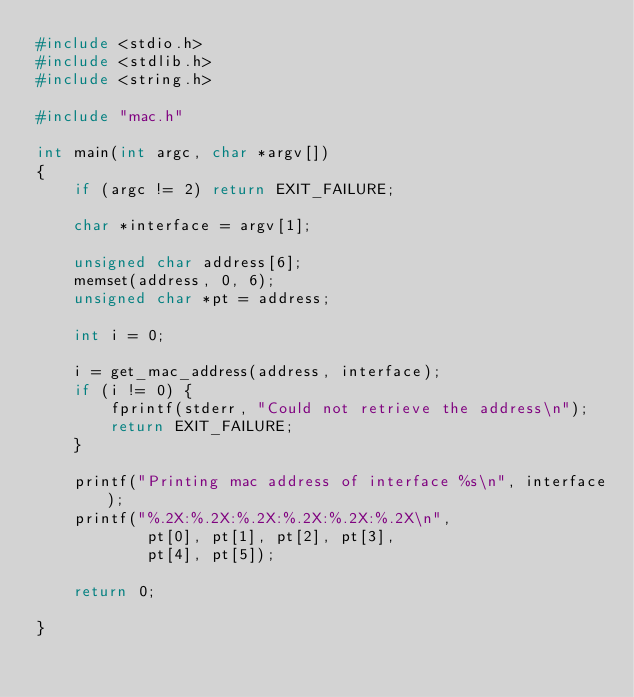Convert code to text. <code><loc_0><loc_0><loc_500><loc_500><_C_>#include <stdio.h>
#include <stdlib.h>
#include <string.h>

#include "mac.h"

int main(int argc, char *argv[])
{
    if (argc != 2) return EXIT_FAILURE;

    char *interface = argv[1];

    unsigned char address[6];
    memset(address, 0, 6);
    unsigned char *pt = address;

    int i = 0;

    i = get_mac_address(address, interface);
    if (i != 0) {
        fprintf(stderr, "Could not retrieve the address\n");
        return EXIT_FAILURE;
    }

    printf("Printing mac address of interface %s\n", interface);
    printf("%.2X:%.2X:%.2X:%.2X:%.2X:%.2X\n",
            pt[0], pt[1], pt[2], pt[3],
            pt[4], pt[5]);

    return 0;

}
</code> 